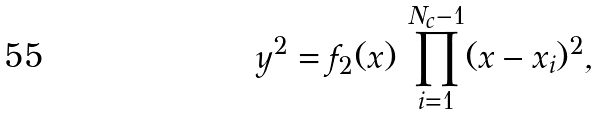Convert formula to latex. <formula><loc_0><loc_0><loc_500><loc_500>y ^ { 2 } = f _ { 2 } ( x ) \, \prod _ { i = 1 } ^ { N _ { c } - 1 } ( x - x _ { i } ) ^ { 2 } ,</formula> 